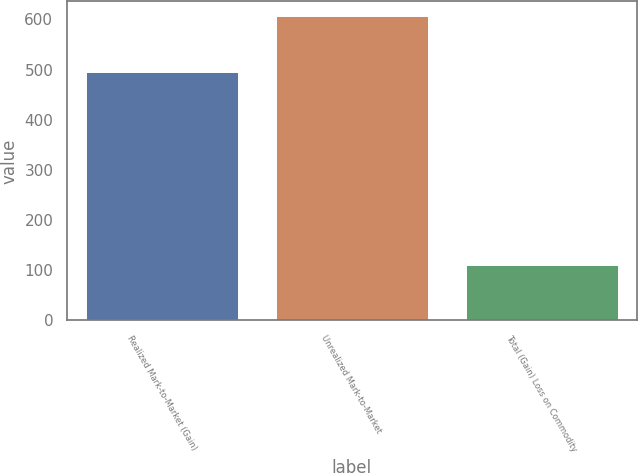Convert chart to OTSL. <chart><loc_0><loc_0><loc_500><loc_500><bar_chart><fcel>Realized Mark-to-Market (Gain)<fcel>Unrealized Mark-to-Market<fcel>Total (Gain) Loss on Commodity<nl><fcel>496<fcel>606<fcel>110<nl></chart> 